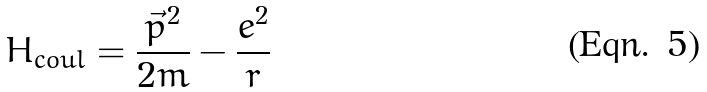Convert formula to latex. <formula><loc_0><loc_0><loc_500><loc_500>H _ { c o u l } = \frac { \vec { p } ^ { 2 } } { 2 m } - \frac { e ^ { 2 } } { r }</formula> 